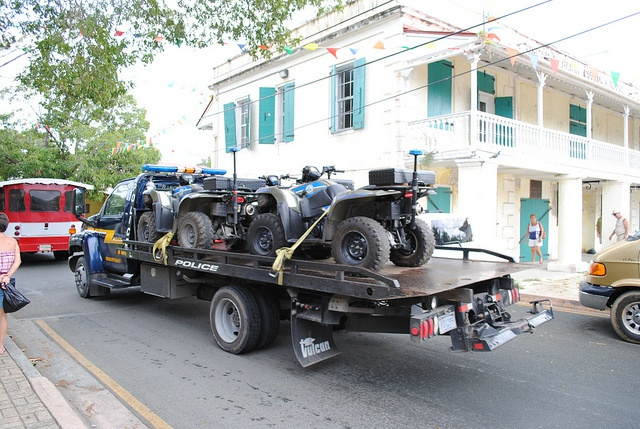Describe the objects in this image and their specific colors. I can see truck in olive, black, gray, darkgray, and lightgray tones, bus in olive, lavender, black, and brown tones, car in olive, black, gray, darkgray, and tan tones, people in olive, pink, lightpink, and black tones, and people in olive, lavender, tan, darkgray, and salmon tones in this image. 